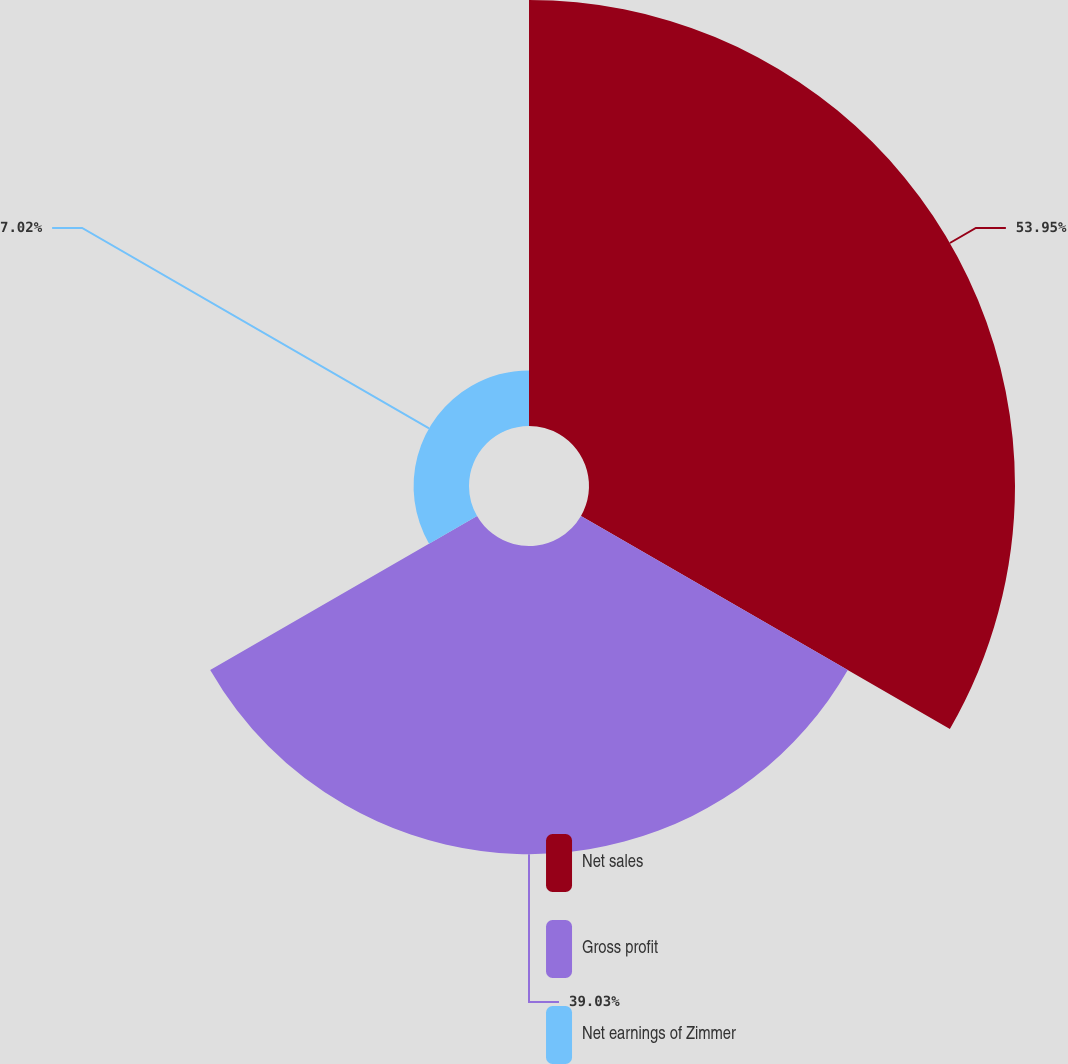Convert chart to OTSL. <chart><loc_0><loc_0><loc_500><loc_500><pie_chart><fcel>Net sales<fcel>Gross profit<fcel>Net earnings of Zimmer<nl><fcel>53.96%<fcel>39.03%<fcel>7.02%<nl></chart> 